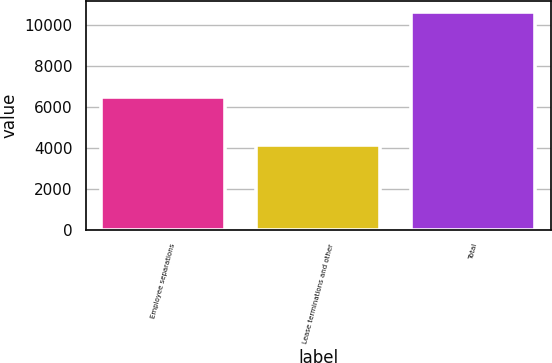Convert chart to OTSL. <chart><loc_0><loc_0><loc_500><loc_500><bar_chart><fcel>Employee separations<fcel>Lease terminations and other<fcel>Total<nl><fcel>6501<fcel>4137<fcel>10638<nl></chart> 